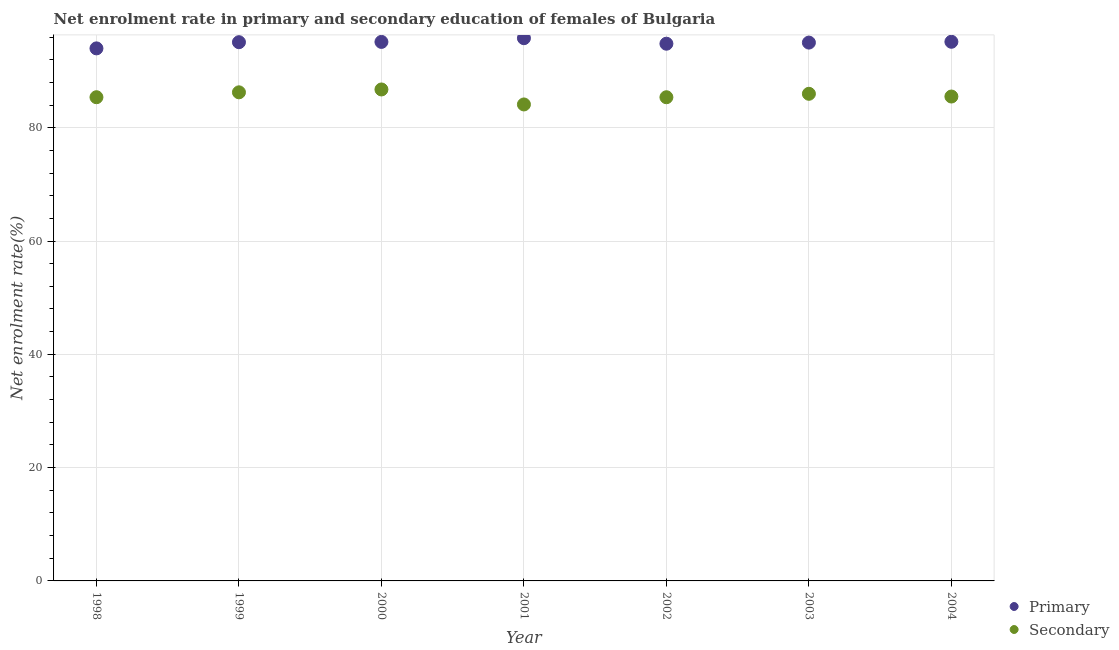What is the enrollment rate in secondary education in 2002?
Give a very brief answer. 85.38. Across all years, what is the maximum enrollment rate in secondary education?
Ensure brevity in your answer.  86.75. Across all years, what is the minimum enrollment rate in primary education?
Offer a terse response. 94. In which year was the enrollment rate in secondary education maximum?
Make the answer very short. 2000. What is the total enrollment rate in secondary education in the graph?
Make the answer very short. 599.35. What is the difference between the enrollment rate in primary education in 2002 and that in 2004?
Ensure brevity in your answer.  -0.34. What is the difference between the enrollment rate in primary education in 2003 and the enrollment rate in secondary education in 2001?
Provide a succinct answer. 10.92. What is the average enrollment rate in primary education per year?
Give a very brief answer. 95.01. In the year 2004, what is the difference between the enrollment rate in primary education and enrollment rate in secondary education?
Your response must be concise. 9.67. What is the ratio of the enrollment rate in secondary education in 2003 to that in 2004?
Provide a succinct answer. 1.01. Is the difference between the enrollment rate in primary education in 2002 and 2003 greater than the difference between the enrollment rate in secondary education in 2002 and 2003?
Keep it short and to the point. Yes. What is the difference between the highest and the second highest enrollment rate in secondary education?
Provide a succinct answer. 0.51. What is the difference between the highest and the lowest enrollment rate in primary education?
Offer a terse response. 1.8. Is the sum of the enrollment rate in primary education in 2000 and 2001 greater than the maximum enrollment rate in secondary education across all years?
Make the answer very short. Yes. Does the enrollment rate in primary education monotonically increase over the years?
Make the answer very short. No. Is the enrollment rate in secondary education strictly less than the enrollment rate in primary education over the years?
Give a very brief answer. Yes. How many years are there in the graph?
Give a very brief answer. 7. What is the difference between two consecutive major ticks on the Y-axis?
Make the answer very short. 20. Does the graph contain grids?
Provide a succinct answer. Yes. How many legend labels are there?
Provide a short and direct response. 2. How are the legend labels stacked?
Offer a very short reply. Vertical. What is the title of the graph?
Make the answer very short. Net enrolment rate in primary and secondary education of females of Bulgaria. What is the label or title of the Y-axis?
Keep it short and to the point. Net enrolment rate(%). What is the Net enrolment rate(%) in Primary in 1998?
Provide a succinct answer. 94. What is the Net enrolment rate(%) in Secondary in 1998?
Make the answer very short. 85.38. What is the Net enrolment rate(%) in Primary in 1999?
Provide a short and direct response. 95.1. What is the Net enrolment rate(%) of Secondary in 1999?
Ensure brevity in your answer.  86.25. What is the Net enrolment rate(%) in Primary in 2000?
Give a very brief answer. 95.15. What is the Net enrolment rate(%) in Secondary in 2000?
Your answer should be compact. 86.75. What is the Net enrolment rate(%) in Primary in 2001?
Your answer should be compact. 95.8. What is the Net enrolment rate(%) in Secondary in 2001?
Ensure brevity in your answer.  84.11. What is the Net enrolment rate(%) in Primary in 2002?
Give a very brief answer. 94.83. What is the Net enrolment rate(%) of Secondary in 2002?
Offer a very short reply. 85.38. What is the Net enrolment rate(%) in Primary in 2003?
Provide a succinct answer. 95.02. What is the Net enrolment rate(%) of Secondary in 2003?
Keep it short and to the point. 85.99. What is the Net enrolment rate(%) of Primary in 2004?
Offer a very short reply. 95.17. What is the Net enrolment rate(%) of Secondary in 2004?
Your answer should be compact. 85.5. Across all years, what is the maximum Net enrolment rate(%) of Primary?
Your answer should be compact. 95.8. Across all years, what is the maximum Net enrolment rate(%) in Secondary?
Make the answer very short. 86.75. Across all years, what is the minimum Net enrolment rate(%) of Primary?
Keep it short and to the point. 94. Across all years, what is the minimum Net enrolment rate(%) of Secondary?
Ensure brevity in your answer.  84.11. What is the total Net enrolment rate(%) in Primary in the graph?
Offer a very short reply. 665.07. What is the total Net enrolment rate(%) of Secondary in the graph?
Your answer should be compact. 599.35. What is the difference between the Net enrolment rate(%) of Primary in 1998 and that in 1999?
Your answer should be very brief. -1.09. What is the difference between the Net enrolment rate(%) of Secondary in 1998 and that in 1999?
Offer a terse response. -0.86. What is the difference between the Net enrolment rate(%) in Primary in 1998 and that in 2000?
Your response must be concise. -1.14. What is the difference between the Net enrolment rate(%) of Secondary in 1998 and that in 2000?
Provide a short and direct response. -1.37. What is the difference between the Net enrolment rate(%) of Primary in 1998 and that in 2001?
Your response must be concise. -1.8. What is the difference between the Net enrolment rate(%) in Secondary in 1998 and that in 2001?
Offer a terse response. 1.28. What is the difference between the Net enrolment rate(%) of Primary in 1998 and that in 2002?
Your response must be concise. -0.82. What is the difference between the Net enrolment rate(%) in Secondary in 1998 and that in 2002?
Your response must be concise. 0. What is the difference between the Net enrolment rate(%) of Primary in 1998 and that in 2003?
Provide a short and direct response. -1.02. What is the difference between the Net enrolment rate(%) in Secondary in 1998 and that in 2003?
Offer a very short reply. -0.6. What is the difference between the Net enrolment rate(%) in Primary in 1998 and that in 2004?
Ensure brevity in your answer.  -1.17. What is the difference between the Net enrolment rate(%) of Secondary in 1998 and that in 2004?
Your answer should be very brief. -0.12. What is the difference between the Net enrolment rate(%) in Primary in 1999 and that in 2000?
Your answer should be compact. -0.05. What is the difference between the Net enrolment rate(%) of Secondary in 1999 and that in 2000?
Make the answer very short. -0.51. What is the difference between the Net enrolment rate(%) in Primary in 1999 and that in 2001?
Offer a very short reply. -0.71. What is the difference between the Net enrolment rate(%) of Secondary in 1999 and that in 2001?
Provide a succinct answer. 2.14. What is the difference between the Net enrolment rate(%) of Primary in 1999 and that in 2002?
Keep it short and to the point. 0.27. What is the difference between the Net enrolment rate(%) in Secondary in 1999 and that in 2002?
Ensure brevity in your answer.  0.87. What is the difference between the Net enrolment rate(%) of Primary in 1999 and that in 2003?
Ensure brevity in your answer.  0.07. What is the difference between the Net enrolment rate(%) in Secondary in 1999 and that in 2003?
Give a very brief answer. 0.26. What is the difference between the Net enrolment rate(%) of Primary in 1999 and that in 2004?
Your answer should be very brief. -0.07. What is the difference between the Net enrolment rate(%) of Secondary in 1999 and that in 2004?
Provide a short and direct response. 0.74. What is the difference between the Net enrolment rate(%) in Primary in 2000 and that in 2001?
Provide a succinct answer. -0.66. What is the difference between the Net enrolment rate(%) of Secondary in 2000 and that in 2001?
Keep it short and to the point. 2.65. What is the difference between the Net enrolment rate(%) in Primary in 2000 and that in 2002?
Give a very brief answer. 0.32. What is the difference between the Net enrolment rate(%) of Secondary in 2000 and that in 2002?
Offer a terse response. 1.37. What is the difference between the Net enrolment rate(%) in Primary in 2000 and that in 2003?
Your answer should be compact. 0.12. What is the difference between the Net enrolment rate(%) in Secondary in 2000 and that in 2003?
Your answer should be compact. 0.77. What is the difference between the Net enrolment rate(%) of Primary in 2000 and that in 2004?
Offer a terse response. -0.02. What is the difference between the Net enrolment rate(%) of Secondary in 2000 and that in 2004?
Keep it short and to the point. 1.25. What is the difference between the Net enrolment rate(%) of Primary in 2001 and that in 2002?
Ensure brevity in your answer.  0.98. What is the difference between the Net enrolment rate(%) in Secondary in 2001 and that in 2002?
Ensure brevity in your answer.  -1.27. What is the difference between the Net enrolment rate(%) in Primary in 2001 and that in 2003?
Your answer should be very brief. 0.78. What is the difference between the Net enrolment rate(%) in Secondary in 2001 and that in 2003?
Provide a succinct answer. -1.88. What is the difference between the Net enrolment rate(%) of Primary in 2001 and that in 2004?
Give a very brief answer. 0.63. What is the difference between the Net enrolment rate(%) in Secondary in 2001 and that in 2004?
Offer a very short reply. -1.4. What is the difference between the Net enrolment rate(%) in Primary in 2002 and that in 2003?
Your answer should be compact. -0.2. What is the difference between the Net enrolment rate(%) in Secondary in 2002 and that in 2003?
Your answer should be very brief. -0.61. What is the difference between the Net enrolment rate(%) in Primary in 2002 and that in 2004?
Provide a succinct answer. -0.34. What is the difference between the Net enrolment rate(%) in Secondary in 2002 and that in 2004?
Keep it short and to the point. -0.12. What is the difference between the Net enrolment rate(%) of Primary in 2003 and that in 2004?
Keep it short and to the point. -0.14. What is the difference between the Net enrolment rate(%) in Secondary in 2003 and that in 2004?
Your response must be concise. 0.48. What is the difference between the Net enrolment rate(%) of Primary in 1998 and the Net enrolment rate(%) of Secondary in 1999?
Your response must be concise. 7.76. What is the difference between the Net enrolment rate(%) in Primary in 1998 and the Net enrolment rate(%) in Secondary in 2000?
Ensure brevity in your answer.  7.25. What is the difference between the Net enrolment rate(%) in Primary in 1998 and the Net enrolment rate(%) in Secondary in 2001?
Provide a short and direct response. 9.9. What is the difference between the Net enrolment rate(%) in Primary in 1998 and the Net enrolment rate(%) in Secondary in 2002?
Your answer should be compact. 8.62. What is the difference between the Net enrolment rate(%) of Primary in 1998 and the Net enrolment rate(%) of Secondary in 2003?
Offer a very short reply. 8.02. What is the difference between the Net enrolment rate(%) in Primary in 1998 and the Net enrolment rate(%) in Secondary in 2004?
Offer a very short reply. 8.5. What is the difference between the Net enrolment rate(%) in Primary in 1999 and the Net enrolment rate(%) in Secondary in 2000?
Provide a succinct answer. 8.34. What is the difference between the Net enrolment rate(%) in Primary in 1999 and the Net enrolment rate(%) in Secondary in 2001?
Provide a succinct answer. 10.99. What is the difference between the Net enrolment rate(%) of Primary in 1999 and the Net enrolment rate(%) of Secondary in 2002?
Provide a succinct answer. 9.72. What is the difference between the Net enrolment rate(%) in Primary in 1999 and the Net enrolment rate(%) in Secondary in 2003?
Keep it short and to the point. 9.11. What is the difference between the Net enrolment rate(%) of Primary in 1999 and the Net enrolment rate(%) of Secondary in 2004?
Offer a terse response. 9.59. What is the difference between the Net enrolment rate(%) of Primary in 2000 and the Net enrolment rate(%) of Secondary in 2001?
Offer a terse response. 11.04. What is the difference between the Net enrolment rate(%) of Primary in 2000 and the Net enrolment rate(%) of Secondary in 2002?
Ensure brevity in your answer.  9.77. What is the difference between the Net enrolment rate(%) in Primary in 2000 and the Net enrolment rate(%) in Secondary in 2003?
Your answer should be compact. 9.16. What is the difference between the Net enrolment rate(%) of Primary in 2000 and the Net enrolment rate(%) of Secondary in 2004?
Your answer should be compact. 9.64. What is the difference between the Net enrolment rate(%) in Primary in 2001 and the Net enrolment rate(%) in Secondary in 2002?
Your answer should be compact. 10.42. What is the difference between the Net enrolment rate(%) in Primary in 2001 and the Net enrolment rate(%) in Secondary in 2003?
Offer a very short reply. 9.82. What is the difference between the Net enrolment rate(%) in Primary in 2001 and the Net enrolment rate(%) in Secondary in 2004?
Offer a terse response. 10.3. What is the difference between the Net enrolment rate(%) in Primary in 2002 and the Net enrolment rate(%) in Secondary in 2003?
Provide a succinct answer. 8.84. What is the difference between the Net enrolment rate(%) of Primary in 2002 and the Net enrolment rate(%) of Secondary in 2004?
Offer a very short reply. 9.32. What is the difference between the Net enrolment rate(%) in Primary in 2003 and the Net enrolment rate(%) in Secondary in 2004?
Your answer should be compact. 9.52. What is the average Net enrolment rate(%) of Primary per year?
Your response must be concise. 95.01. What is the average Net enrolment rate(%) of Secondary per year?
Make the answer very short. 85.62. In the year 1998, what is the difference between the Net enrolment rate(%) of Primary and Net enrolment rate(%) of Secondary?
Your response must be concise. 8.62. In the year 1999, what is the difference between the Net enrolment rate(%) of Primary and Net enrolment rate(%) of Secondary?
Offer a very short reply. 8.85. In the year 2000, what is the difference between the Net enrolment rate(%) of Primary and Net enrolment rate(%) of Secondary?
Your answer should be very brief. 8.39. In the year 2001, what is the difference between the Net enrolment rate(%) in Primary and Net enrolment rate(%) in Secondary?
Ensure brevity in your answer.  11.7. In the year 2002, what is the difference between the Net enrolment rate(%) of Primary and Net enrolment rate(%) of Secondary?
Give a very brief answer. 9.45. In the year 2003, what is the difference between the Net enrolment rate(%) in Primary and Net enrolment rate(%) in Secondary?
Give a very brief answer. 9.04. In the year 2004, what is the difference between the Net enrolment rate(%) of Primary and Net enrolment rate(%) of Secondary?
Offer a terse response. 9.67. What is the ratio of the Net enrolment rate(%) in Primary in 1998 to that in 2000?
Your answer should be compact. 0.99. What is the ratio of the Net enrolment rate(%) in Secondary in 1998 to that in 2000?
Provide a short and direct response. 0.98. What is the ratio of the Net enrolment rate(%) of Primary in 1998 to that in 2001?
Your response must be concise. 0.98. What is the ratio of the Net enrolment rate(%) of Secondary in 1998 to that in 2001?
Ensure brevity in your answer.  1.02. What is the ratio of the Net enrolment rate(%) of Primary in 1998 to that in 2002?
Your response must be concise. 0.99. What is the ratio of the Net enrolment rate(%) of Secondary in 1998 to that in 2002?
Your answer should be compact. 1. What is the ratio of the Net enrolment rate(%) of Secondary in 1998 to that in 2003?
Ensure brevity in your answer.  0.99. What is the ratio of the Net enrolment rate(%) of Secondary in 1998 to that in 2004?
Offer a very short reply. 1. What is the ratio of the Net enrolment rate(%) of Primary in 1999 to that in 2000?
Keep it short and to the point. 1. What is the ratio of the Net enrolment rate(%) in Secondary in 1999 to that in 2000?
Your answer should be very brief. 0.99. What is the ratio of the Net enrolment rate(%) in Primary in 1999 to that in 2001?
Make the answer very short. 0.99. What is the ratio of the Net enrolment rate(%) in Secondary in 1999 to that in 2001?
Provide a succinct answer. 1.03. What is the ratio of the Net enrolment rate(%) of Primary in 1999 to that in 2002?
Your answer should be very brief. 1. What is the ratio of the Net enrolment rate(%) in Secondary in 1999 to that in 2002?
Your answer should be very brief. 1.01. What is the ratio of the Net enrolment rate(%) of Secondary in 1999 to that in 2003?
Offer a very short reply. 1. What is the ratio of the Net enrolment rate(%) of Primary in 1999 to that in 2004?
Offer a very short reply. 1. What is the ratio of the Net enrolment rate(%) in Secondary in 1999 to that in 2004?
Ensure brevity in your answer.  1.01. What is the ratio of the Net enrolment rate(%) in Primary in 2000 to that in 2001?
Provide a short and direct response. 0.99. What is the ratio of the Net enrolment rate(%) in Secondary in 2000 to that in 2001?
Your answer should be very brief. 1.03. What is the ratio of the Net enrolment rate(%) of Primary in 2000 to that in 2002?
Your response must be concise. 1. What is the ratio of the Net enrolment rate(%) in Secondary in 2000 to that in 2002?
Offer a very short reply. 1.02. What is the ratio of the Net enrolment rate(%) in Secondary in 2000 to that in 2003?
Give a very brief answer. 1.01. What is the ratio of the Net enrolment rate(%) of Primary in 2000 to that in 2004?
Offer a very short reply. 1. What is the ratio of the Net enrolment rate(%) in Secondary in 2000 to that in 2004?
Provide a succinct answer. 1.01. What is the ratio of the Net enrolment rate(%) of Primary in 2001 to that in 2002?
Offer a very short reply. 1.01. What is the ratio of the Net enrolment rate(%) of Secondary in 2001 to that in 2002?
Give a very brief answer. 0.99. What is the ratio of the Net enrolment rate(%) of Primary in 2001 to that in 2003?
Provide a succinct answer. 1.01. What is the ratio of the Net enrolment rate(%) of Secondary in 2001 to that in 2003?
Make the answer very short. 0.98. What is the ratio of the Net enrolment rate(%) in Primary in 2001 to that in 2004?
Provide a succinct answer. 1.01. What is the ratio of the Net enrolment rate(%) of Secondary in 2001 to that in 2004?
Offer a very short reply. 0.98. What is the ratio of the Net enrolment rate(%) of Secondary in 2002 to that in 2003?
Your answer should be compact. 0.99. What is the ratio of the Net enrolment rate(%) of Primary in 2002 to that in 2004?
Keep it short and to the point. 1. What is the ratio of the Net enrolment rate(%) in Secondary in 2002 to that in 2004?
Your answer should be very brief. 1. What is the ratio of the Net enrolment rate(%) of Primary in 2003 to that in 2004?
Your response must be concise. 1. What is the ratio of the Net enrolment rate(%) in Secondary in 2003 to that in 2004?
Offer a terse response. 1.01. What is the difference between the highest and the second highest Net enrolment rate(%) of Primary?
Provide a short and direct response. 0.63. What is the difference between the highest and the second highest Net enrolment rate(%) in Secondary?
Your answer should be compact. 0.51. What is the difference between the highest and the lowest Net enrolment rate(%) of Primary?
Offer a very short reply. 1.8. What is the difference between the highest and the lowest Net enrolment rate(%) in Secondary?
Ensure brevity in your answer.  2.65. 